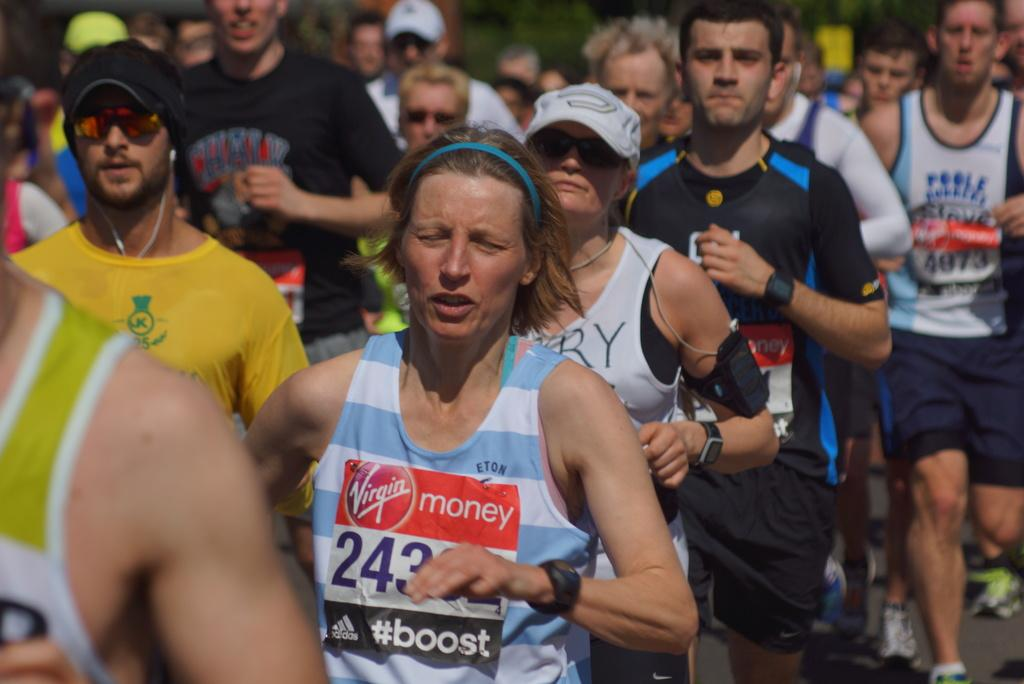What is happening in the image? There is a group of people in the image, and they are running on the road. Can you describe the background of the image? The background of the image is blurred. What type of wood can be seen in the image? There is no wood present in the image; it features a group of people running on the road with a blurred background. 